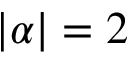<formula> <loc_0><loc_0><loc_500><loc_500>| \alpha | = 2</formula> 